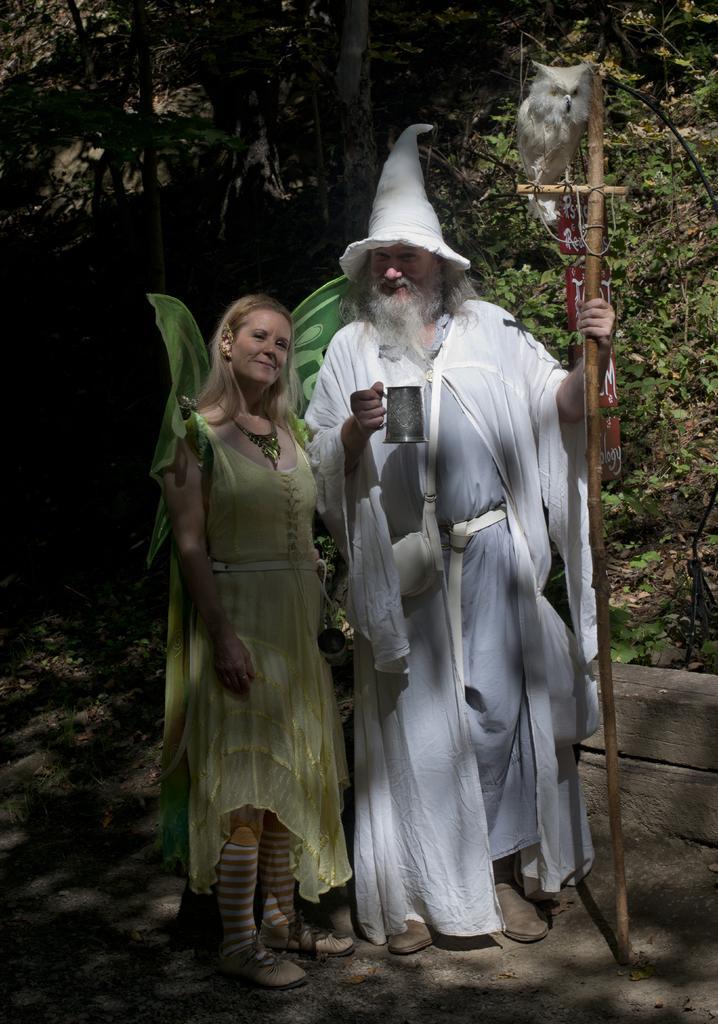Can you describe this image briefly? In the image there is a lady with wings on her back. Beside him there is a man standing and holding the cup in his hand and there is a cap on his head. And also he is holding the stick with an owl on it. Behind them there are trees. In the bottom right corner of the image there is a small wall.  